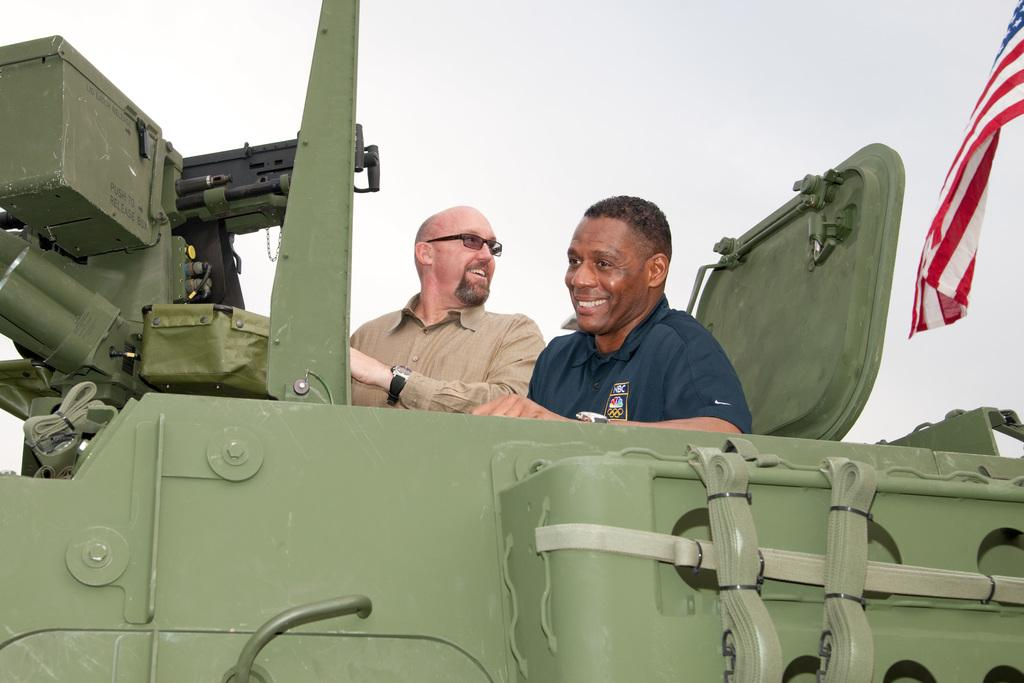What type of vehicle is in the image? There is a military armored car in the image. Who is present in the image? There are two men sitting in the image. What symbol can be seen in the image? There is a flag in the image. What is visible in the background of the image? The sky is visible in the image. How many times does the man walk around the armored car in the image? There is no indication in the image that the man is walking around the armored car, so it cannot be determined. 